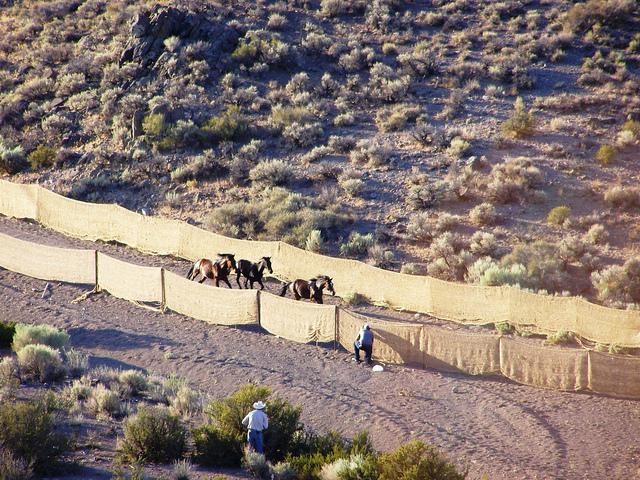Where are the horses?
Be succinct. In desert. Is this taken in a desert?
Give a very brief answer. Yes. Who is hiding behind a bush?
Write a very short answer. Man. 